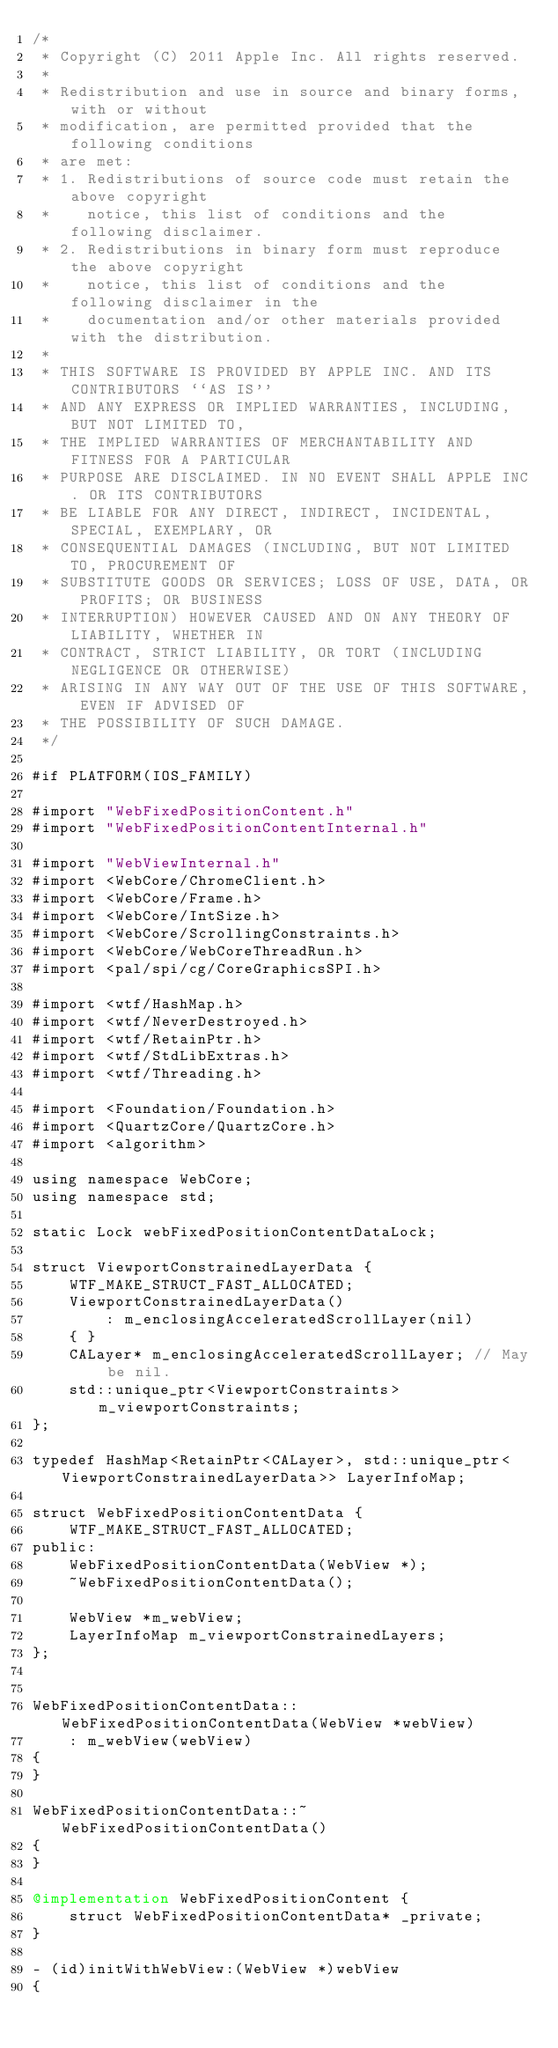Convert code to text. <code><loc_0><loc_0><loc_500><loc_500><_ObjectiveC_>/*
 * Copyright (C) 2011 Apple Inc. All rights reserved.
 *
 * Redistribution and use in source and binary forms, with or without
 * modification, are permitted provided that the following conditions
 * are met:
 * 1. Redistributions of source code must retain the above copyright
 *    notice, this list of conditions and the following disclaimer.
 * 2. Redistributions in binary form must reproduce the above copyright
 *    notice, this list of conditions and the following disclaimer in the
 *    documentation and/or other materials provided with the distribution.
 *
 * THIS SOFTWARE IS PROVIDED BY APPLE INC. AND ITS CONTRIBUTORS ``AS IS''
 * AND ANY EXPRESS OR IMPLIED WARRANTIES, INCLUDING, BUT NOT LIMITED TO,
 * THE IMPLIED WARRANTIES OF MERCHANTABILITY AND FITNESS FOR A PARTICULAR
 * PURPOSE ARE DISCLAIMED. IN NO EVENT SHALL APPLE INC. OR ITS CONTRIBUTORS
 * BE LIABLE FOR ANY DIRECT, INDIRECT, INCIDENTAL, SPECIAL, EXEMPLARY, OR
 * CONSEQUENTIAL DAMAGES (INCLUDING, BUT NOT LIMITED TO, PROCUREMENT OF
 * SUBSTITUTE GOODS OR SERVICES; LOSS OF USE, DATA, OR PROFITS; OR BUSINESS
 * INTERRUPTION) HOWEVER CAUSED AND ON ANY THEORY OF LIABILITY, WHETHER IN
 * CONTRACT, STRICT LIABILITY, OR TORT (INCLUDING NEGLIGENCE OR OTHERWISE)
 * ARISING IN ANY WAY OUT OF THE USE OF THIS SOFTWARE, EVEN IF ADVISED OF
 * THE POSSIBILITY OF SUCH DAMAGE.
 */

#if PLATFORM(IOS_FAMILY)

#import "WebFixedPositionContent.h"
#import "WebFixedPositionContentInternal.h"

#import "WebViewInternal.h"
#import <WebCore/ChromeClient.h>
#import <WebCore/Frame.h>
#import <WebCore/IntSize.h>
#import <WebCore/ScrollingConstraints.h>
#import <WebCore/WebCoreThreadRun.h>
#import <pal/spi/cg/CoreGraphicsSPI.h>

#import <wtf/HashMap.h>
#import <wtf/NeverDestroyed.h>
#import <wtf/RetainPtr.h>
#import <wtf/StdLibExtras.h>
#import <wtf/Threading.h>

#import <Foundation/Foundation.h>
#import <QuartzCore/QuartzCore.h>
#import <algorithm>

using namespace WebCore;
using namespace std;

static Lock webFixedPositionContentDataLock;

struct ViewportConstrainedLayerData {
    WTF_MAKE_STRUCT_FAST_ALLOCATED;
    ViewportConstrainedLayerData()
        : m_enclosingAcceleratedScrollLayer(nil)
    { }
    CALayer* m_enclosingAcceleratedScrollLayer; // May be nil.
    std::unique_ptr<ViewportConstraints> m_viewportConstraints;
};

typedef HashMap<RetainPtr<CALayer>, std::unique_ptr<ViewportConstrainedLayerData>> LayerInfoMap;

struct WebFixedPositionContentData {
    WTF_MAKE_STRUCT_FAST_ALLOCATED;
public:
    WebFixedPositionContentData(WebView *);
    ~WebFixedPositionContentData();
    
    WebView *m_webView;
    LayerInfoMap m_viewportConstrainedLayers;
};


WebFixedPositionContentData::WebFixedPositionContentData(WebView *webView)
    : m_webView(webView)
{
}

WebFixedPositionContentData::~WebFixedPositionContentData()
{
}

@implementation WebFixedPositionContent {
    struct WebFixedPositionContentData* _private;
}

- (id)initWithWebView:(WebView *)webView
{</code> 